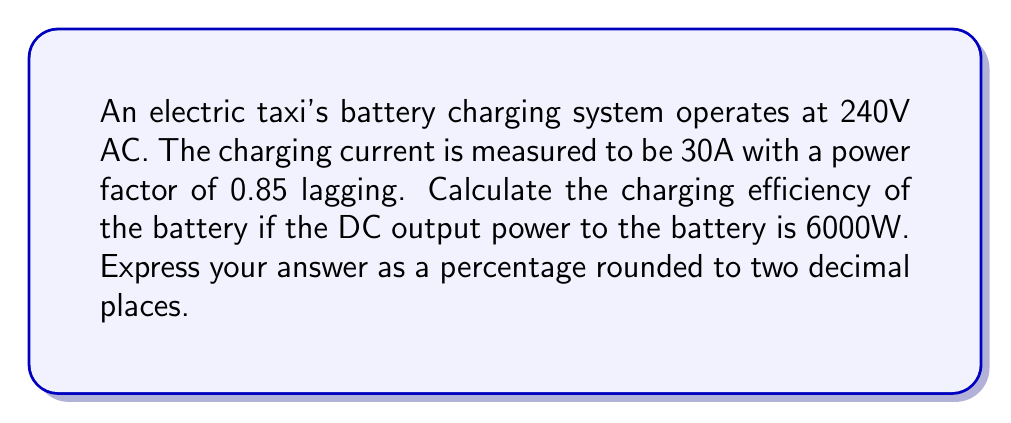What is the answer to this math problem? Let's approach this step-by-step:

1) First, we need to calculate the apparent power S:
   $$S = V \times I = 240V \times 30A = 7200 VA$$

2) The complex power is given by:
   $$S = P + jQ$$
   where P is the real power and Q is the reactive power.

3) We can find the real power P using the power factor:
   $$P = S \times \cos(\theta) = 7200 \times 0.85 = 6120W$$

4) The reactive power Q can be found using the Pythagorean theorem:
   $$Q = \sqrt{S^2 - P^2} = \sqrt{7200^2 - 6120^2} = 3789.47 VAR$$

5) So, the complex power is:
   $$S = 6120 + j3789.47 VA$$

6) The input power to the charging system is the real part of the complex power, 6120W.

7) The output power to the battery is given as 6000W DC.

8) Efficiency is calculated as (Output Power / Input Power) * 100%:
   $$\text{Efficiency} = \frac{6000W}{6120W} \times 100\% = 98.04\%$$
Answer: 98.04% 